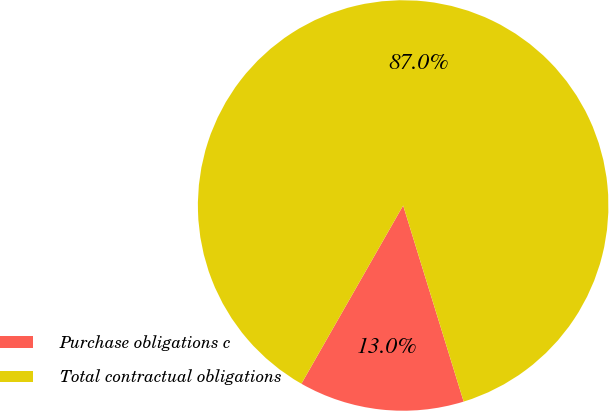Convert chart. <chart><loc_0><loc_0><loc_500><loc_500><pie_chart><fcel>Purchase obligations c<fcel>Total contractual obligations<nl><fcel>13.02%<fcel>86.98%<nl></chart> 